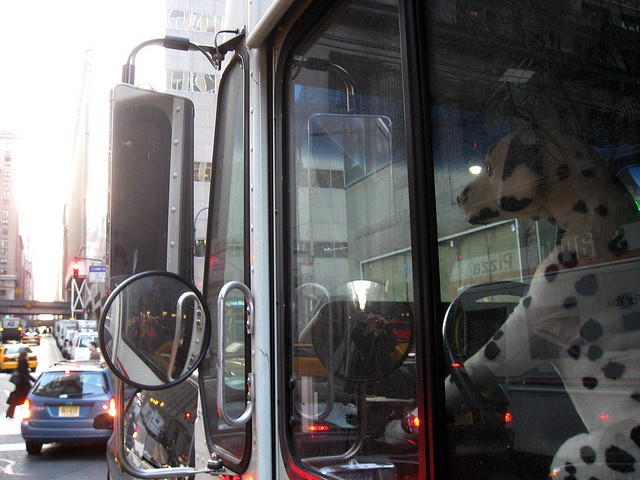Describe the objects in this image and their specific colors. I can see bus in black, white, gray, darkgray, and maroon tones, truck in black, white, gray, darkgray, and lightgray tones, dog in white, black, and gray tones, car in white, gray, and black tones, and people in white, black, maroon, gray, and lightgray tones in this image. 